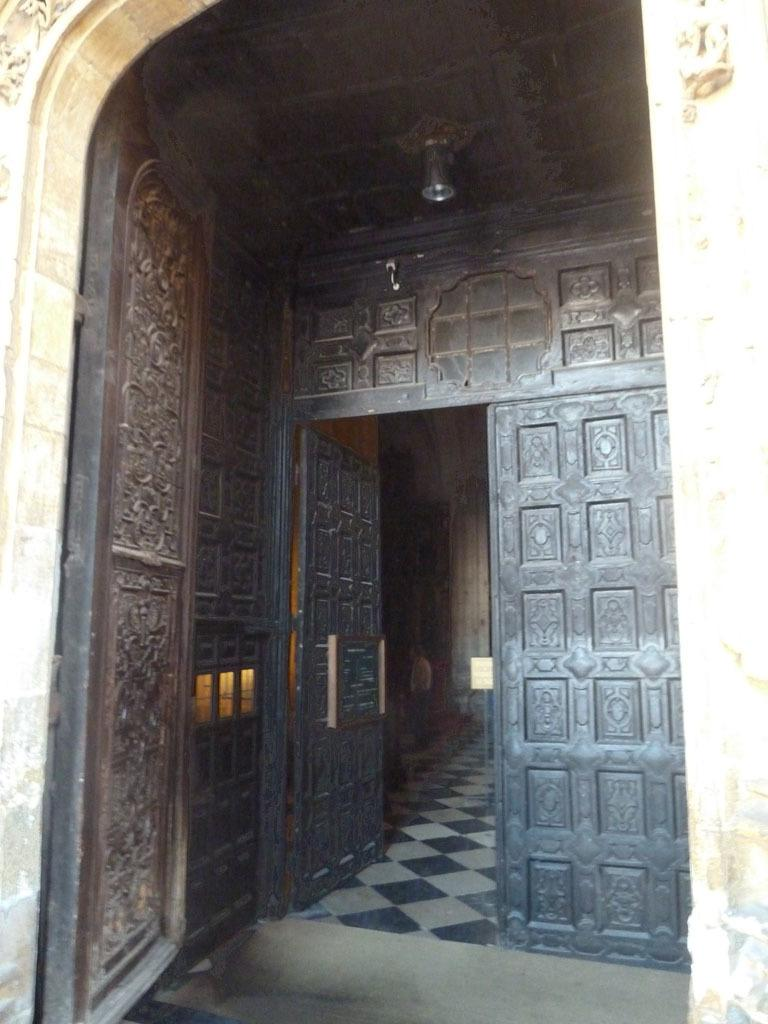What color are the doors in the image? The doors in the image are black. What can be found attached to the ceiling in the image? There is a light attached to the ceiling in the image. What part of the room is visible in the image? The floor is visible in the image. Can you see an owl perched on the light in the image? There is no owl present in the image. 